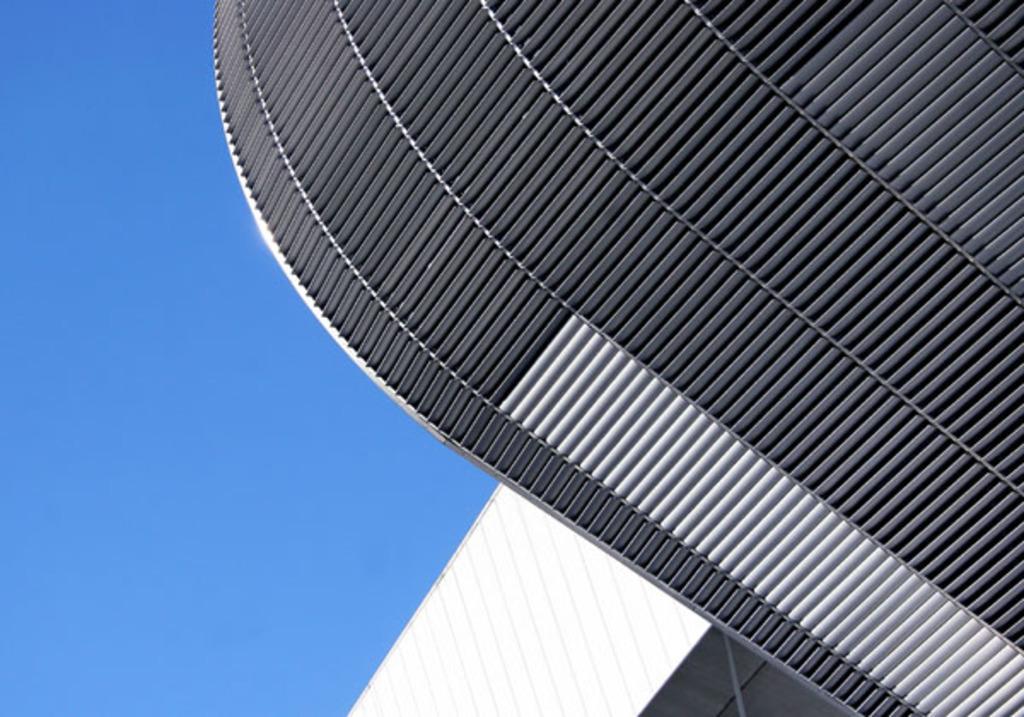Please provide a concise description of this image. In this image there is an architecture, in the background there is the sky. 